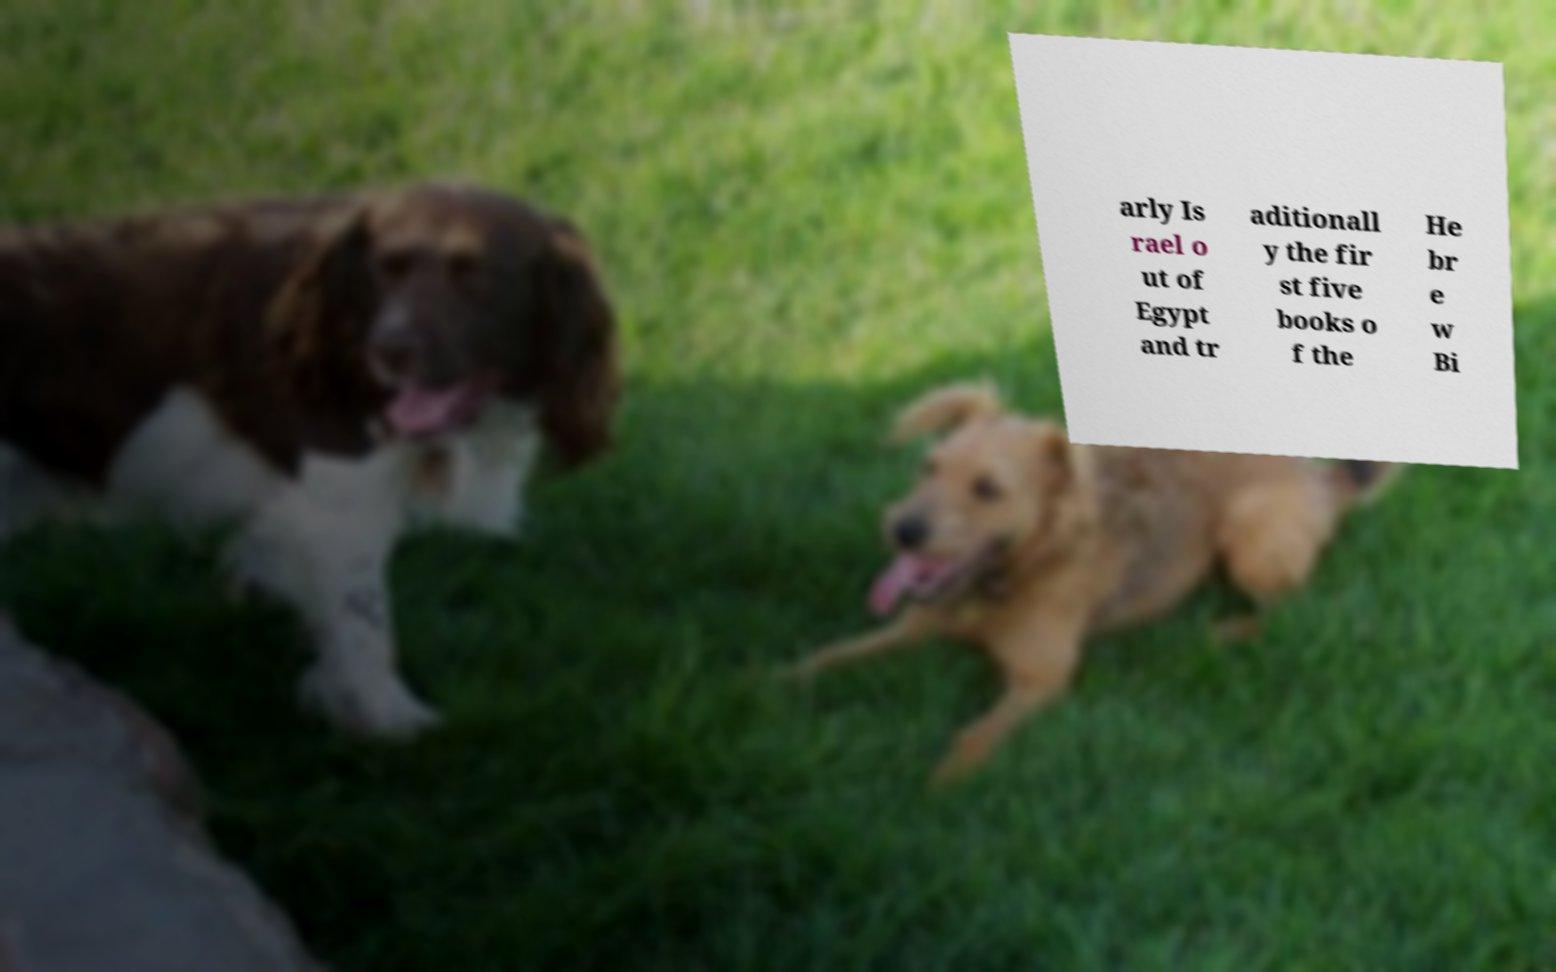There's text embedded in this image that I need extracted. Can you transcribe it verbatim? arly Is rael o ut of Egypt and tr aditionall y the fir st five books o f the He br e w Bi 